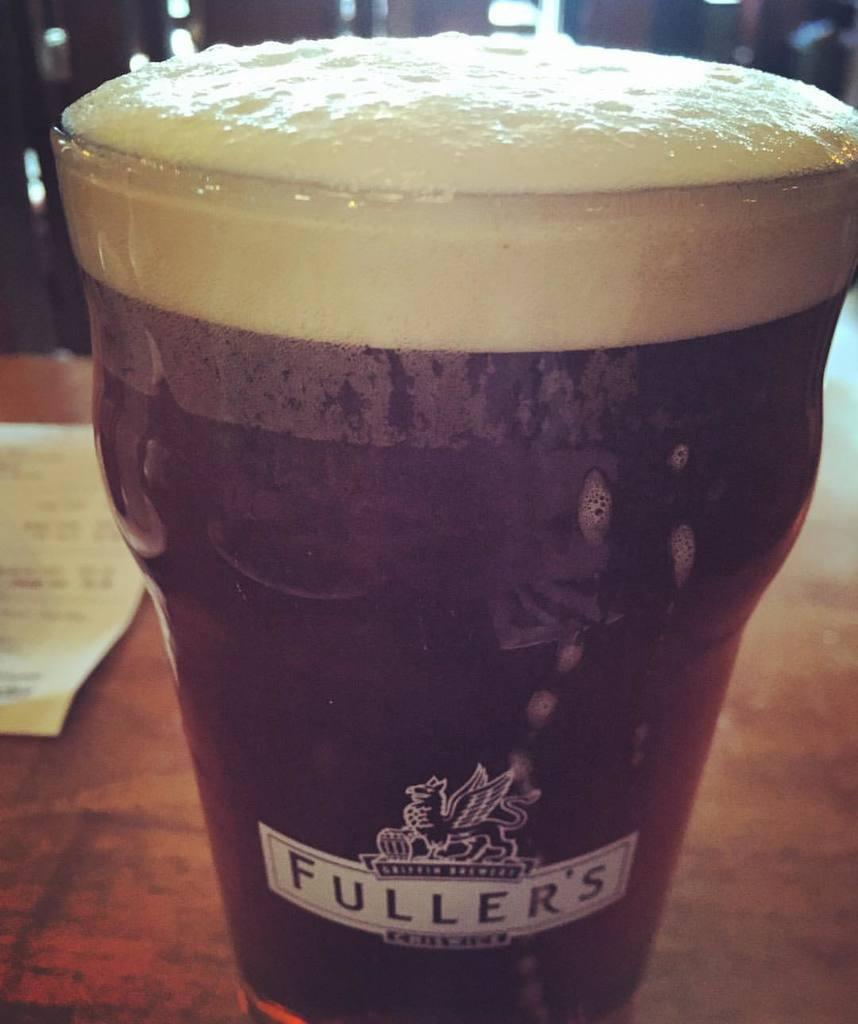What is in the glass that is visible in the image? The glass is filled with a drink. Where is the glass located in the image? The glass is placed on a table. What type of veil is draped over the glass in the image? There is no veil present in the image; the glass is filled with a drink and placed on a table. 